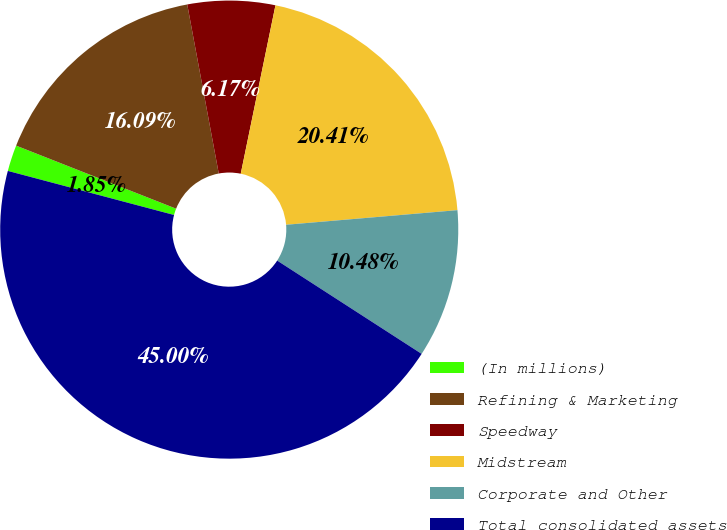<chart> <loc_0><loc_0><loc_500><loc_500><pie_chart><fcel>(In millions)<fcel>Refining & Marketing<fcel>Speedway<fcel>Midstream<fcel>Corporate and Other<fcel>Total consolidated assets<nl><fcel>1.85%<fcel>16.09%<fcel>6.17%<fcel>20.41%<fcel>10.48%<fcel>45.0%<nl></chart> 